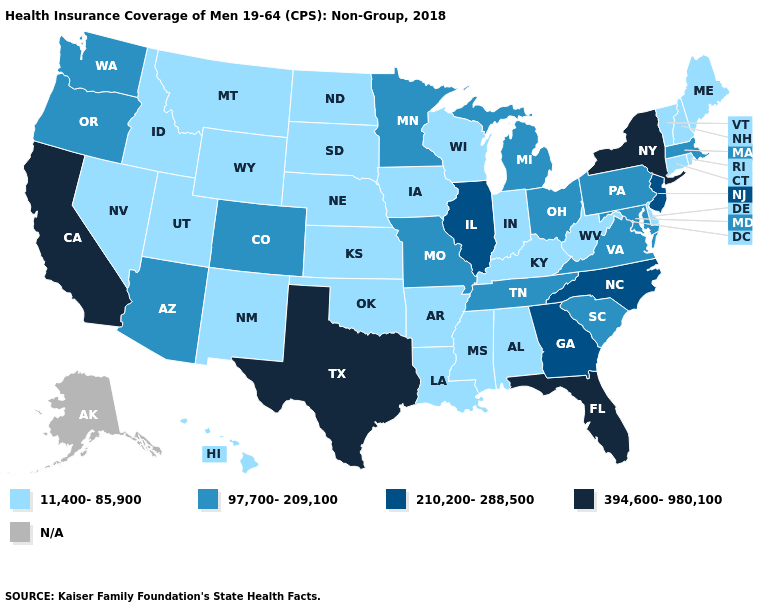What is the value of Georgia?
Short answer required. 210,200-288,500. Is the legend a continuous bar?
Write a very short answer. No. What is the value of Nebraska?
Keep it brief. 11,400-85,900. Name the states that have a value in the range 394,600-980,100?
Quick response, please. California, Florida, New York, Texas. What is the value of Virginia?
Be succinct. 97,700-209,100. What is the value of Arizona?
Give a very brief answer. 97,700-209,100. Does Oklahoma have the lowest value in the South?
Short answer required. Yes. What is the lowest value in the USA?
Quick response, please. 11,400-85,900. Which states have the highest value in the USA?
Write a very short answer. California, Florida, New York, Texas. Among the states that border Maryland , does Pennsylvania have the highest value?
Concise answer only. Yes. Does South Dakota have the highest value in the MidWest?
Be succinct. No. Among the states that border Nevada , which have the lowest value?
Quick response, please. Idaho, Utah. Does Kentucky have the lowest value in the USA?
Concise answer only. Yes. Among the states that border West Virginia , which have the lowest value?
Concise answer only. Kentucky. 